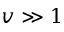Convert formula to latex. <formula><loc_0><loc_0><loc_500><loc_500>v \gg 1</formula> 